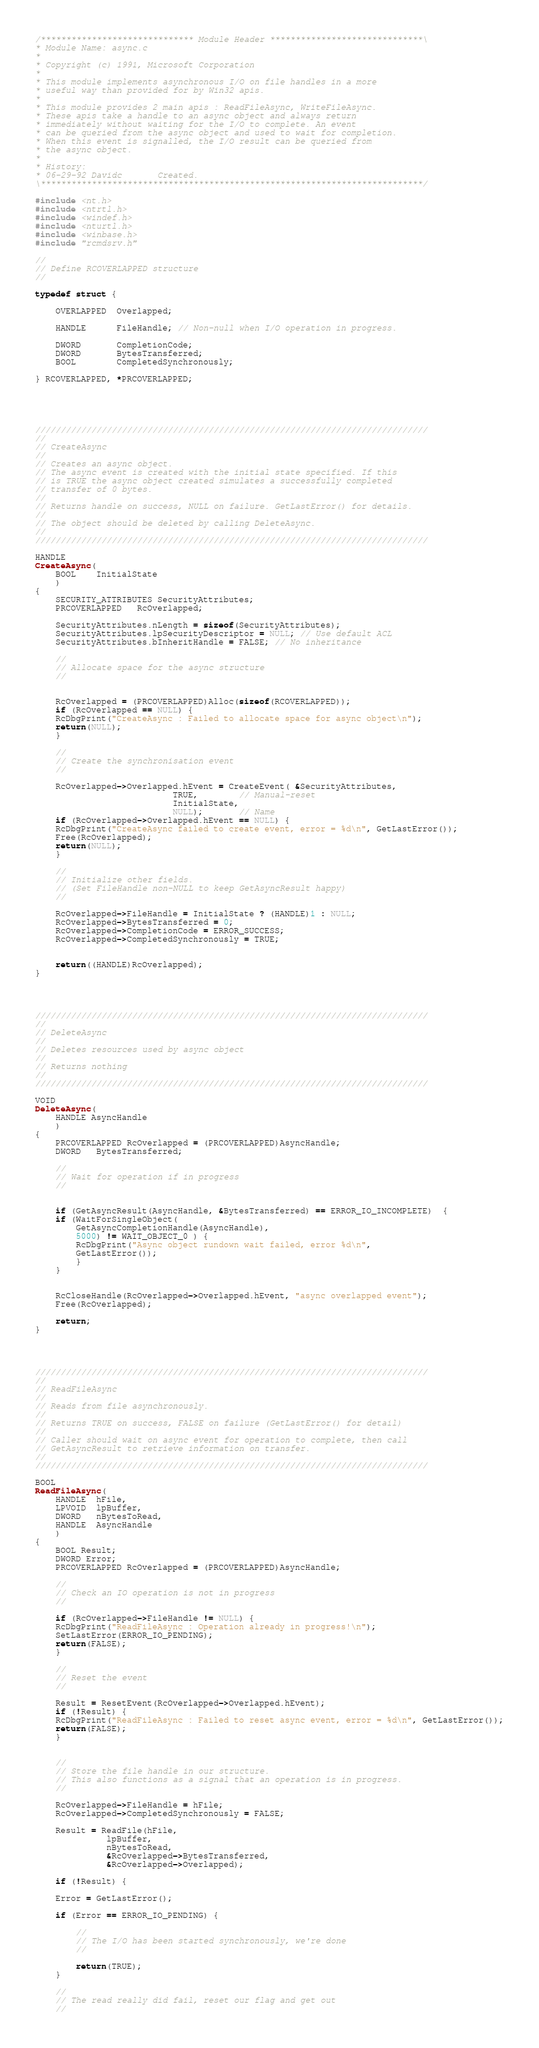<code> <loc_0><loc_0><loc_500><loc_500><_C_>/****************************** Module Header ******************************\
* Module Name: async.c
*
* Copyright (c) 1991, Microsoft Corporation
*
* This module implements asynchronous I/O on file handles in a more
* useful way than provided for by Win32 apis.
*
* This module provides 2 main apis : ReadFileAsync, WriteFileAsync.
* These apis take a handle to an async object and always return
* immediately without waiting for the I/O to complete. An event
* can be queried from the async object and used to wait for completion.
* When this event is signalled, the I/O result can be queried from
* the async object.
*
* History:
* 06-29-92 Davidc       Created.
\***************************************************************************/

#include <nt.h>
#include <ntrtl.h>
#include <windef.h>
#include <nturtl.h>
#include <winbase.h>
#include "rcmdsrv.h"

//
// Define RCOVERLAPPED structure
//

typedef struct {

    OVERLAPPED  Overlapped;

    HANDLE      FileHandle; // Non-null when I/O operation in progress.

    DWORD       CompletionCode;
    DWORD       BytesTransferred;
    BOOL        CompletedSynchronously;

} RCOVERLAPPED, *PRCOVERLAPPED;





/////////////////////////////////////////////////////////////////////////////
//
// CreateAsync
//
// Creates an async object.
// The async event is created with the initial state specified. If this
// is TRUE the async object created simulates a successfully completed
// transfer of 0 bytes.
//
// Returns handle on success, NULL on failure. GetLastError() for details.
//
// The object should be deleted by calling DeleteAsync.
//
/////////////////////////////////////////////////////////////////////////////

HANDLE
CreateAsync(
    BOOL    InitialState
    )
{
    SECURITY_ATTRIBUTES SecurityAttributes;
    PRCOVERLAPPED   RcOverlapped;

    SecurityAttributes.nLength = sizeof(SecurityAttributes);
    SecurityAttributes.lpSecurityDescriptor = NULL; // Use default ACL
    SecurityAttributes.bInheritHandle = FALSE; // No inheritance

    //
    // Allocate space for the async structure
    //


    RcOverlapped = (PRCOVERLAPPED)Alloc(sizeof(RCOVERLAPPED));
    if (RcOverlapped == NULL) {
	RcDbgPrint("CreateAsync : Failed to allocate space for async object\n");
	return(NULL);
    }

    //
    // Create the synchronisation event
    //

    RcOverlapped->Overlapped.hEvent = CreateEvent( &SecurityAttributes,
						   TRUE,        // Manual-reset
						   InitialState,
						   NULL);       // Name
    if (RcOverlapped->Overlapped.hEvent == NULL) {
	RcDbgPrint("CreateAsync failed to create event, error = %d\n", GetLastError());
	Free(RcOverlapped);
	return(NULL);
    }

    //
    // Initialize other fields.
    // (Set FileHandle non-NULL to keep GetAsyncResult happy)
    //

    RcOverlapped->FileHandle = InitialState ? (HANDLE)1 : NULL;
    RcOverlapped->BytesTransferred = 0;
    RcOverlapped->CompletionCode = ERROR_SUCCESS;
    RcOverlapped->CompletedSynchronously = TRUE;


    return((HANDLE)RcOverlapped);
}




/////////////////////////////////////////////////////////////////////////////
//
// DeleteAsync
//
// Deletes resources used by async object
//
// Returns nothing
//
/////////////////////////////////////////////////////////////////////////////

VOID
DeleteAsync(
    HANDLE AsyncHandle
    )
{
    PRCOVERLAPPED RcOverlapped = (PRCOVERLAPPED)AsyncHandle;
    DWORD   BytesTransferred;

    //
    // Wait for operation if in progress
    //


    if (GetAsyncResult(AsyncHandle, &BytesTransferred) == ERROR_IO_INCOMPLETE)  {
	if (WaitForSingleObject(
		GetAsyncCompletionHandle(AsyncHandle),
		5000) != WAIT_OBJECT_0 ) {
	    RcDbgPrint("Async object rundown wait failed, error %d\n",
		GetLastError());
	    }
	}


    RcCloseHandle(RcOverlapped->Overlapped.hEvent, "async overlapped event");
    Free(RcOverlapped);

    return;
}




/////////////////////////////////////////////////////////////////////////////
//
// ReadFileAsync
//
// Reads from file asynchronously.
//
// Returns TRUE on success, FALSE on failure (GetLastError() for detail)
//
// Caller should wait on async event for operation to complete, then call
// GetAsyncResult to retrieve information on transfer.
//
/////////////////////////////////////////////////////////////////////////////

BOOL
ReadFileAsync(
    HANDLE  hFile,
    LPVOID  lpBuffer,
    DWORD   nBytesToRead,
    HANDLE  AsyncHandle
    )
{
    BOOL Result;
    DWORD Error;
    PRCOVERLAPPED RcOverlapped = (PRCOVERLAPPED)AsyncHandle;

    //
    // Check an IO operation is not in progress
    //

    if (RcOverlapped->FileHandle != NULL) {
	RcDbgPrint("ReadFileAsync : Operation already in progress!\n");
	SetLastError(ERROR_IO_PENDING);
	return(FALSE);
    }

    //
    // Reset the event
    //

    Result = ResetEvent(RcOverlapped->Overlapped.hEvent);
    if (!Result) {
	RcDbgPrint("ReadFileAsync : Failed to reset async event, error = %d\n", GetLastError());
	return(FALSE);
    }


    //
    // Store the file handle in our structure.
    // This also functions as a signal that an operation is in progress.
    //

    RcOverlapped->FileHandle = hFile;
    RcOverlapped->CompletedSynchronously = FALSE;

    Result = ReadFile(hFile,
		      lpBuffer,
		      nBytesToRead,
		      &RcOverlapped->BytesTransferred,
		      &RcOverlapped->Overlapped);

    if (!Result) {

	Error = GetLastError();

	if (Error == ERROR_IO_PENDING) {

	    //
	    // The I/O has been started synchronously, we're done
	    //

	    return(TRUE);
	}

	//
	// The read really did fail, reset our flag and get out
	//
</code> 